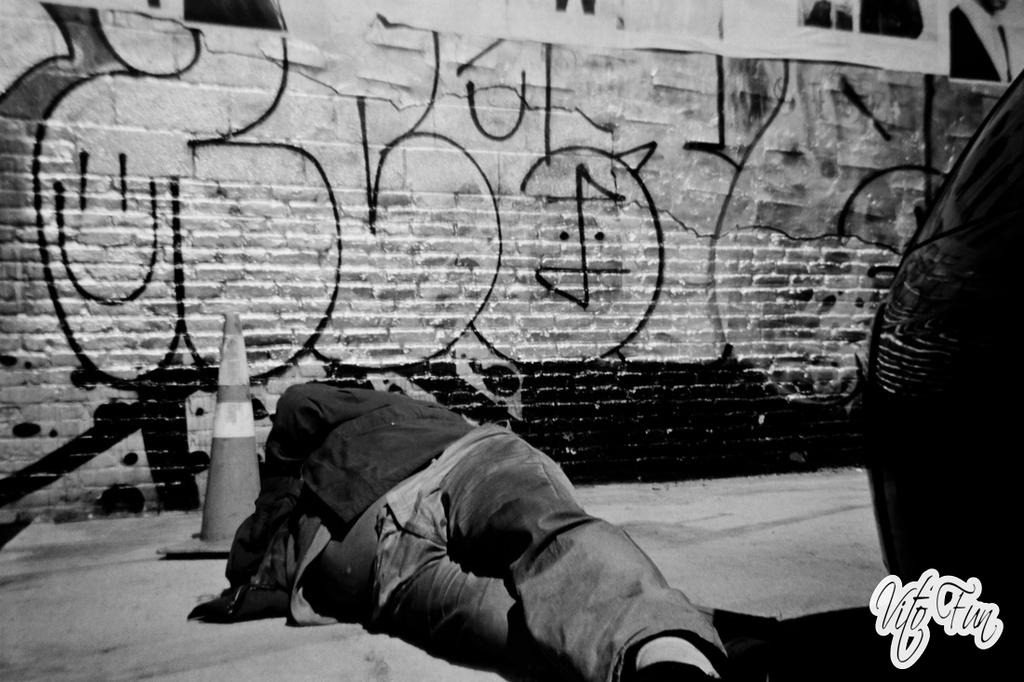What is the person in the image doing? There is a person lying on the surface in the image. What is the black object in the image? There is a black object in the image, but its specific nature is not mentioned in the facts. What is the traffic cone used for in the image? The purpose of the traffic cone in the image is not mentioned in the facts. What can be seen in the background of the image? There are posters and a drawing on the wall in the background of the image. How many legs does the side have in the image? There is no mention of a side or legs in the image. 